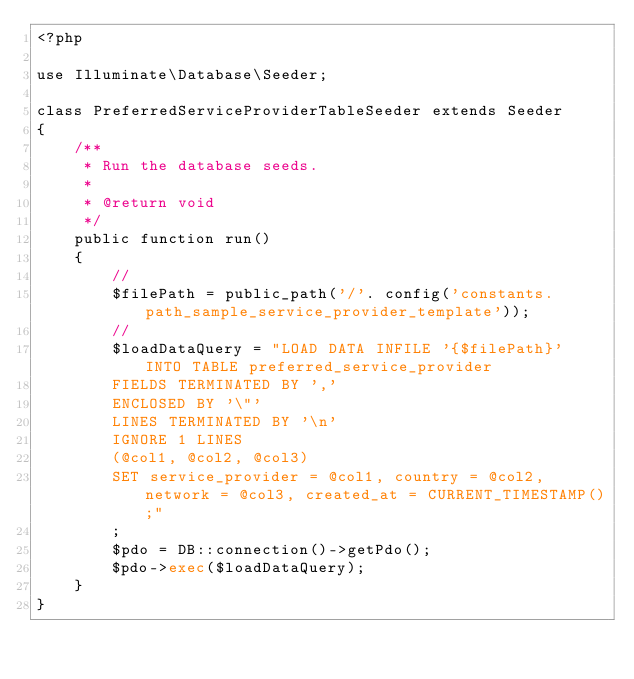Convert code to text. <code><loc_0><loc_0><loc_500><loc_500><_PHP_><?php

use Illuminate\Database\Seeder;

class PreferredServiceProviderTableSeeder extends Seeder
{
    /**
     * Run the database seeds.
     *
     * @return void
     */
    public function run()
    {
        //
        $filePath = public_path('/'. config('constants.path_sample_service_provider_template'));
        //
        $loadDataQuery = "LOAD DATA INFILE '{$filePath}' INTO TABLE preferred_service_provider
        FIELDS TERMINATED BY ','
        ENCLOSED BY '\"'
        LINES TERMINATED BY '\n'
        IGNORE 1 LINES
        (@col1, @col2, @col3)
        SET service_provider = @col1, country = @col2, network = @col3, created_at = CURRENT_TIMESTAMP();"
        ;
        $pdo = DB::connection()->getPdo();
        $pdo->exec($loadDataQuery);
    }
}
</code> 